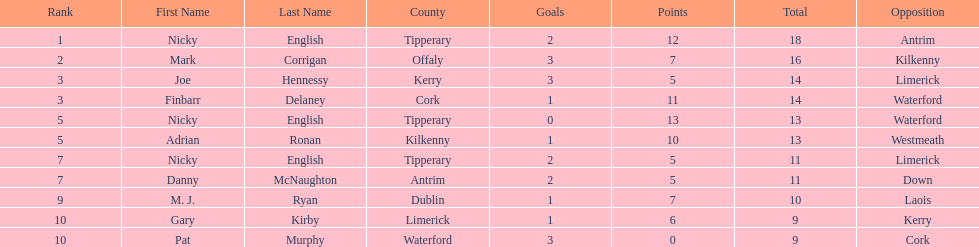What was the average of the totals of nicky english and mark corrigan? 17. 